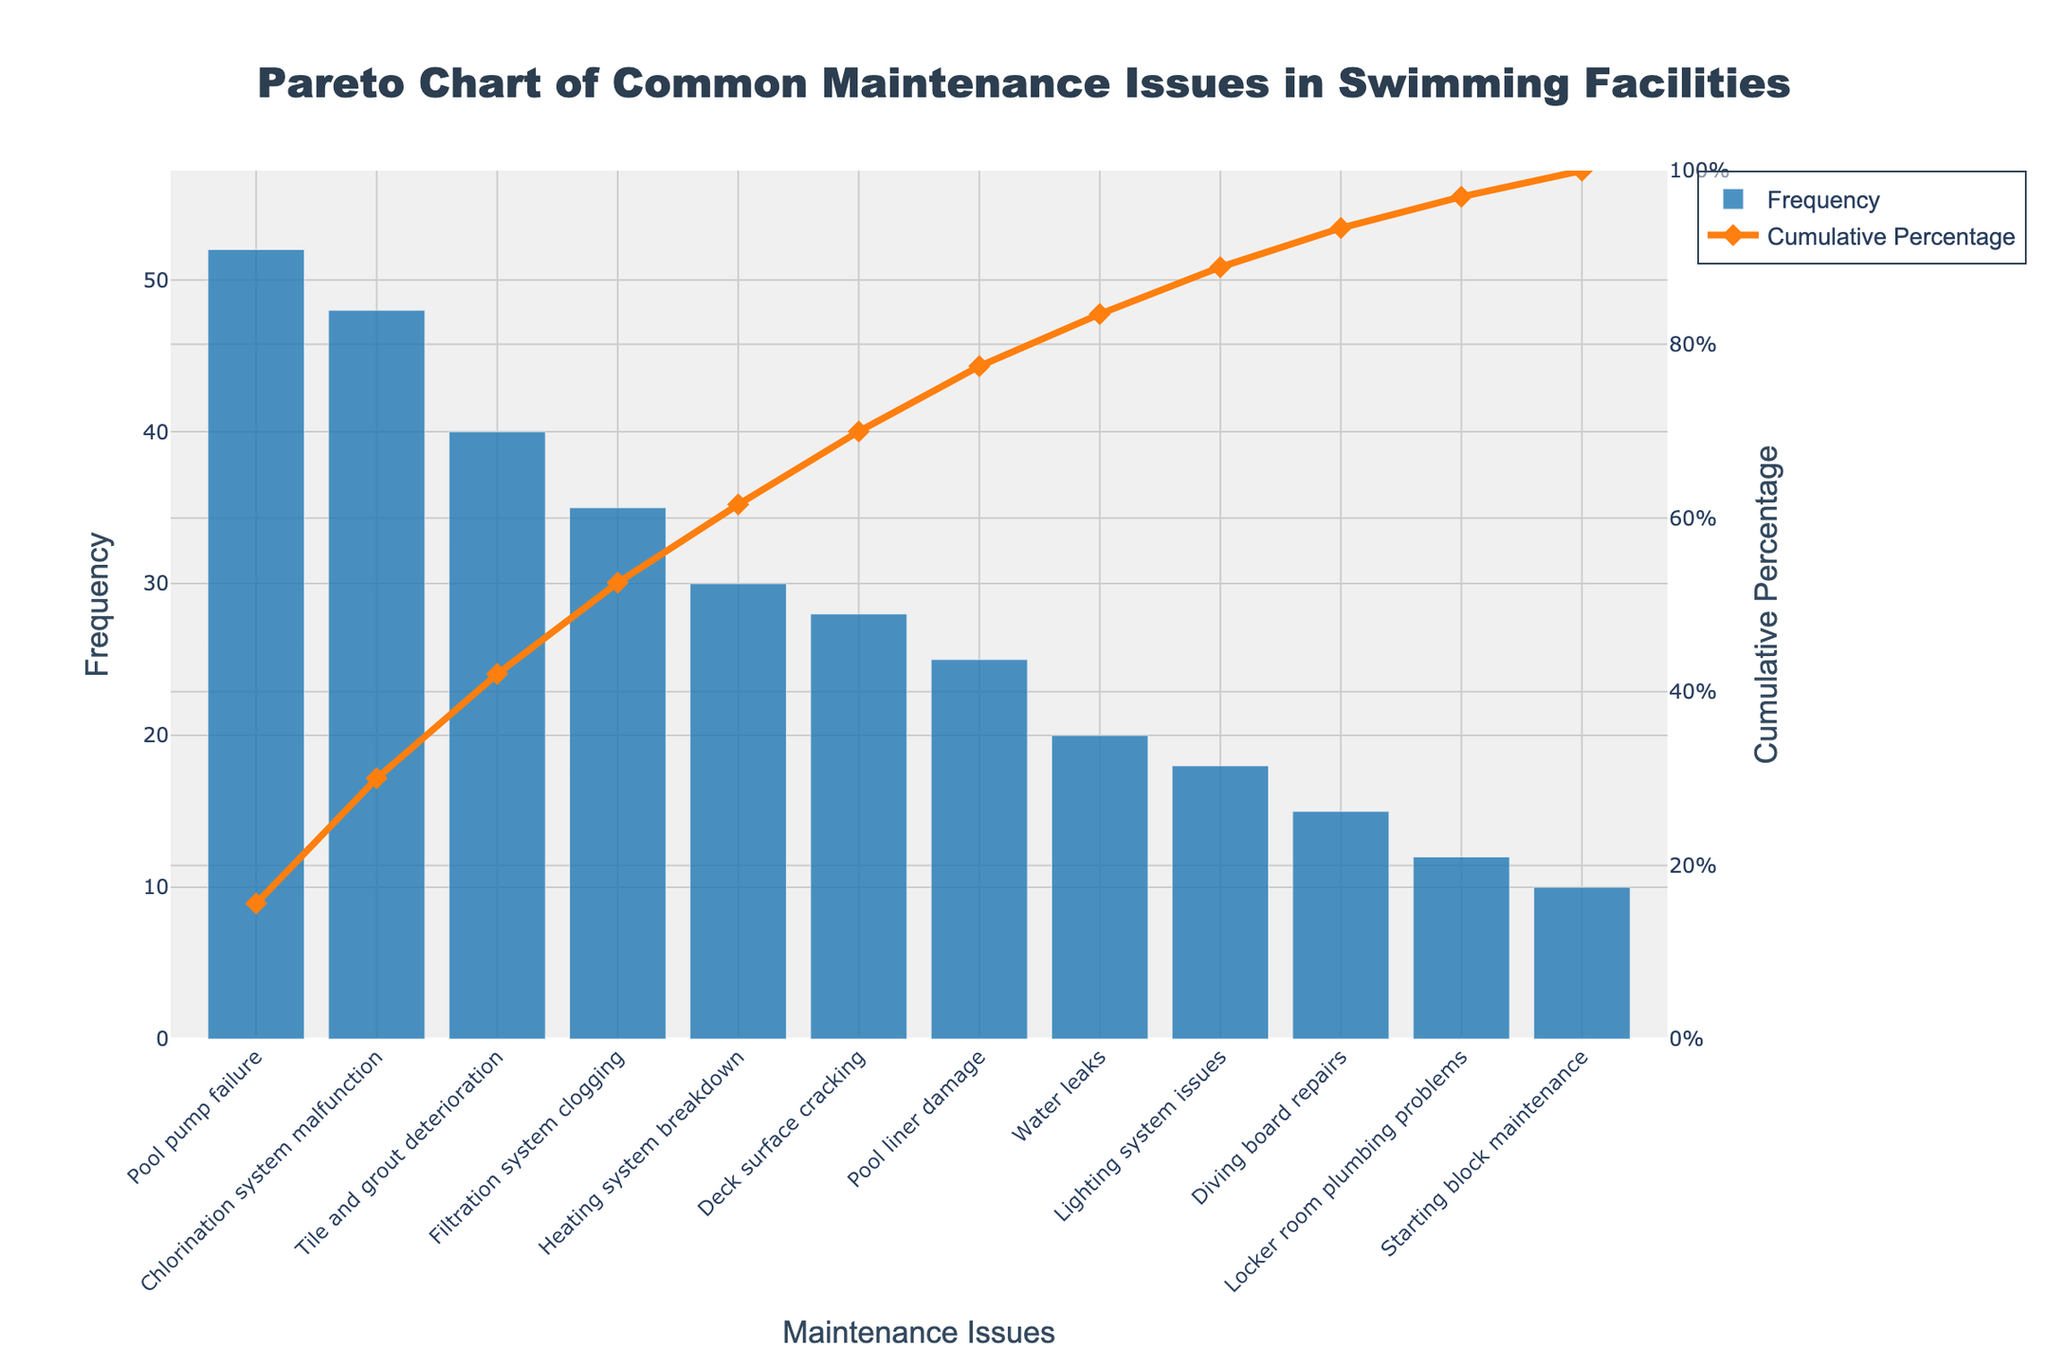What issue has the highest frequency of maintenance? The issue with the highest bar in the bar chart represents the highest frequency. Looking at the data shown on the x-axis, the "Pool pump failure" has the tallest bar.
Answer: Pool pump failure What is the total percentage covered by the top two issues? The cumulative percentage line can be used to find cumulative percentages. Looking at "Pool pump failure" and "Chlorination system malfunction", "Pool pump failure" has a 27.4% and "Chlorination system malfunction" brings it to 52.1%.
Answer: 52.1% Which issue has a higher cumulative percentage, 'Heating system breakdown' or 'Deck surface cracking'? Locate both issues on the x-axis and compare their cumulative percentage from the line chart. The 'Heating system breakdown' is above 'Deck surface cracking' in terms of cumulative percentage.
Answer: Heating system breakdown At what frequency value does the cumulative percentage reach approximately 80%? By following the cumulative percentage line to where it crosses 80% on the y2 axis (right side), it aligns right after the frequency of "Water leaks." Summing the frequency up to "Water leaks" provides around 278.
Answer: 278 How many issues contribute to about 95% of the cumulative percentage? Follow the cumulative percentage line to where it nears 95%, then count the corresponding issues on the x-axis up to that point: The cumulative percentage around "Locker room plumbing problems" indicates 11 issues.
Answer: 11 issues What is the costliest maintenance issue? According to the data table, the "Pool liner damage" has the costliest value of 9000. The plot ranks frequencies and cumulative percentages, so refer back to the dataset for specific costs.
Answer: Pool liner damage Which has a higher frequency, 'Lighting system issues' or 'Starting block maintenance'? Compare their bars' heights. "Lighting system issues" is taller than "Starting block maintenance."
Answer: Lighting system issues How does the frequency of 'Tile and grout deterioration' compare to 'Filtration system clogging'? Refer to the bar heights for both issues. 'Tile and grout deterioration' has a taller bar (40) compared to 'Filtration system clogging' (35).
Answer: Tile and grout deterioration What issue marks the halfway point in the cumulative percentage? The cumulative percentage reaching 50% aids in finding frequently occurring maintenance issues. By examining the line chart, "Chlorination system malfunction" combined with "Pool pump failure" covers around half cumulatively.
Answer: Chlorination system malfunction Which issue directly follows 'Pool liner damage' in terms of cumulative frequency? Locate 'Pool liner damage' on the x-axis, check the adjacent bar to its right. "Water leaks" follows directly next in order.
Answer: Water leaks 